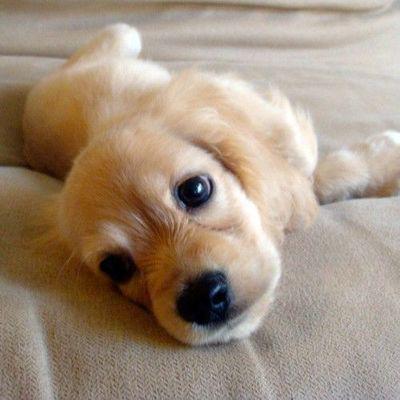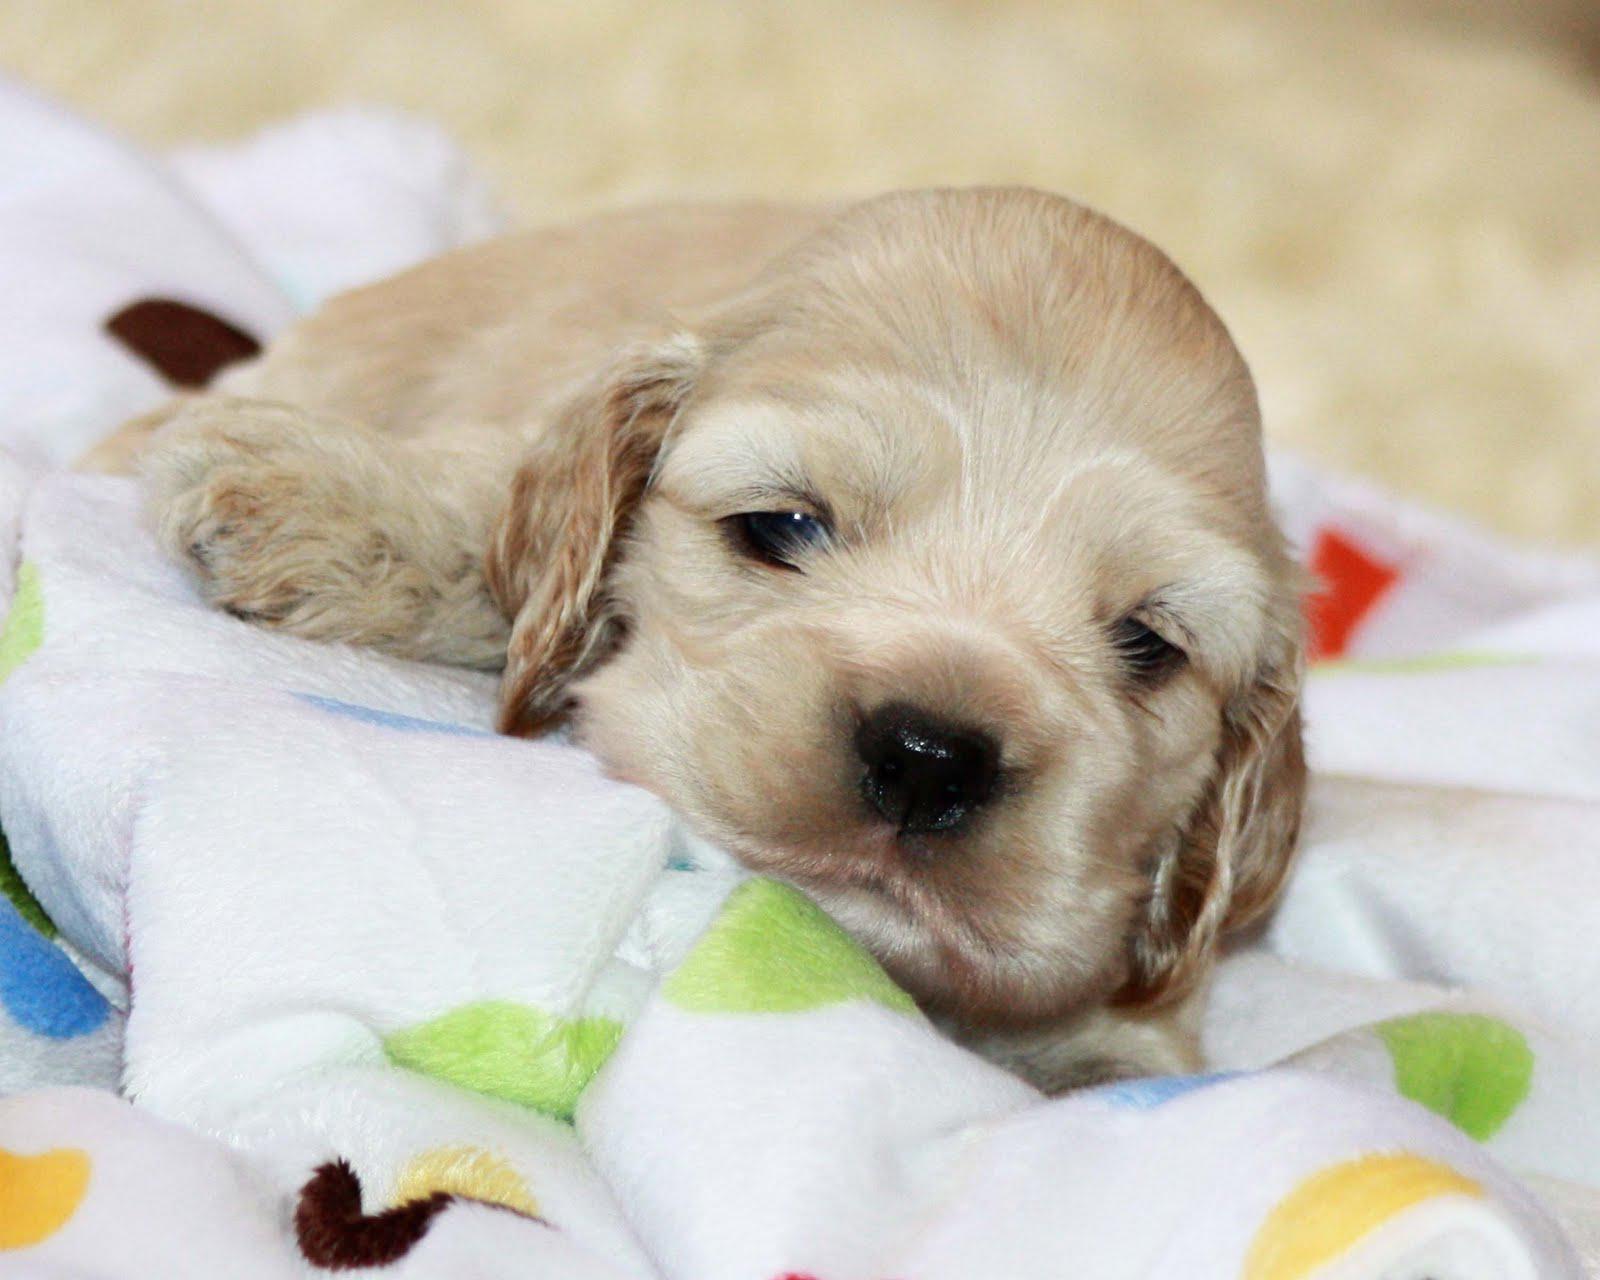The first image is the image on the left, the second image is the image on the right. For the images displayed, is the sentence "The dogs in all of the images are indoors." factually correct? Answer yes or no. Yes. The first image is the image on the left, the second image is the image on the right. Evaluate the accuracy of this statement regarding the images: "The right image features at least one spaniel posed on green grass, and the left image contains just one spaniel, which is white with light orange markings.". Is it true? Answer yes or no. No. 